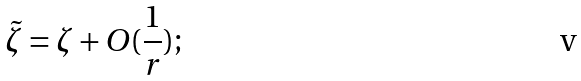<formula> <loc_0><loc_0><loc_500><loc_500>\tilde { \zeta } = \zeta + O ( \frac { 1 } { r } ) ;</formula> 